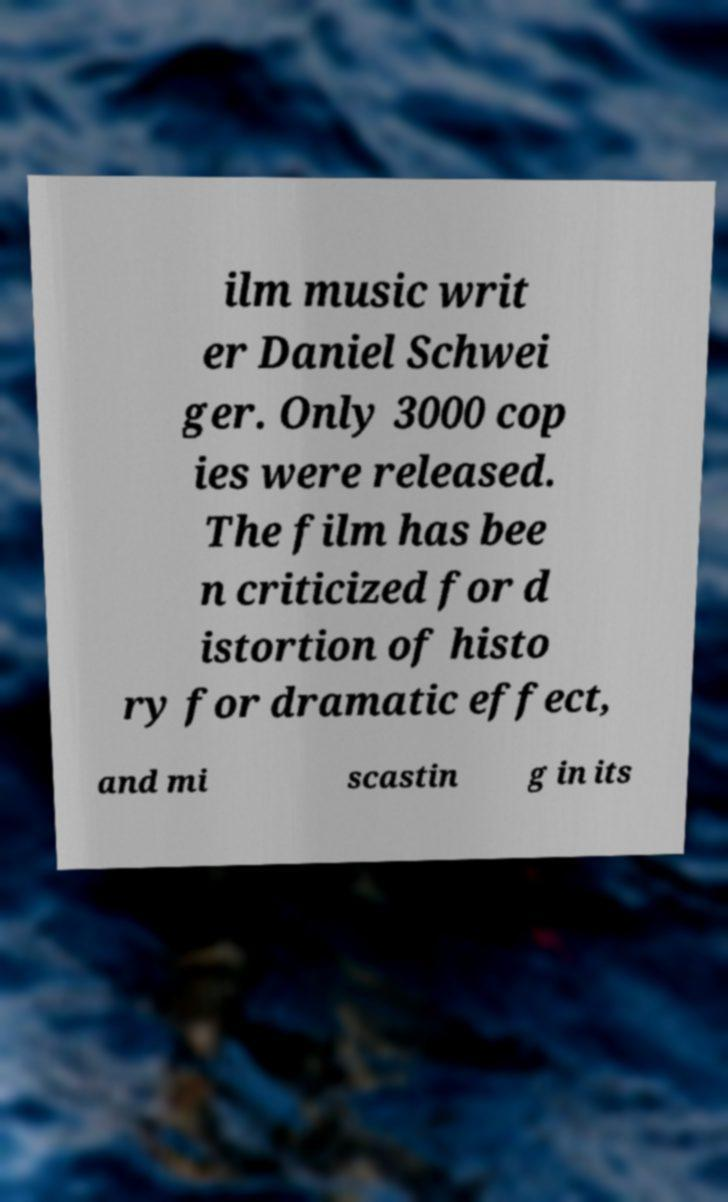For documentation purposes, I need the text within this image transcribed. Could you provide that? ilm music writ er Daniel Schwei ger. Only 3000 cop ies were released. The film has bee n criticized for d istortion of histo ry for dramatic effect, and mi scastin g in its 